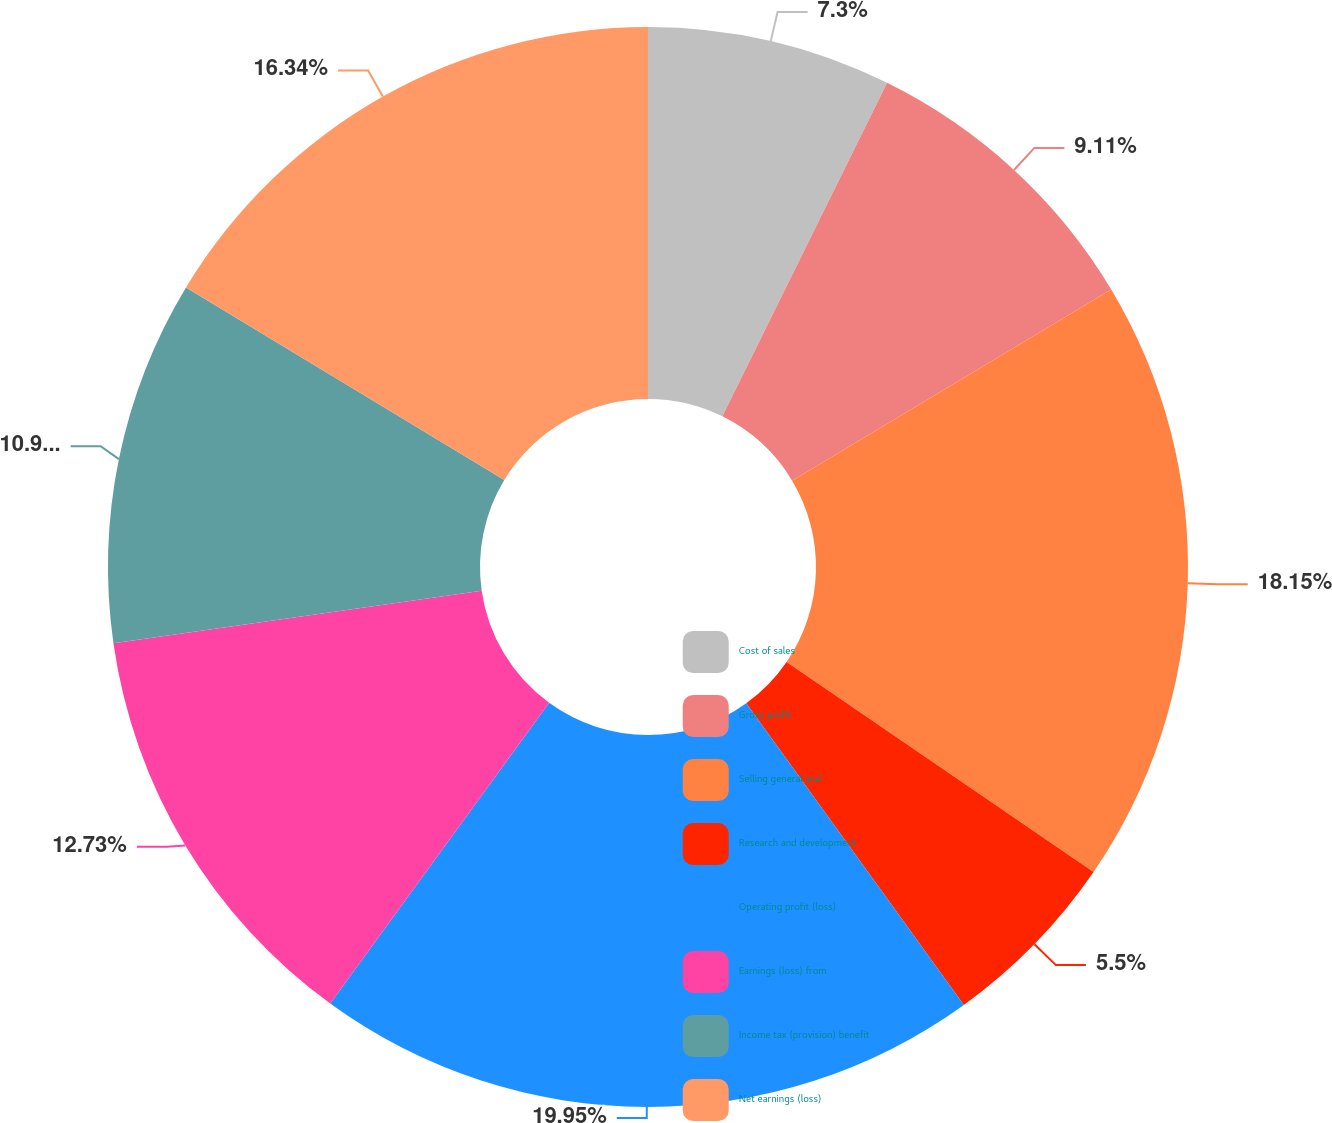<chart> <loc_0><loc_0><loc_500><loc_500><pie_chart><fcel>Cost of sales<fcel>Gross profit<fcel>Selling general and<fcel>Research and development<fcel>Operating profit (loss)<fcel>Earnings (loss) from<fcel>Income tax (provision) benefit<fcel>Net earnings (loss)<nl><fcel>7.3%<fcel>9.11%<fcel>18.15%<fcel>5.5%<fcel>19.96%<fcel>12.73%<fcel>10.92%<fcel>16.34%<nl></chart> 